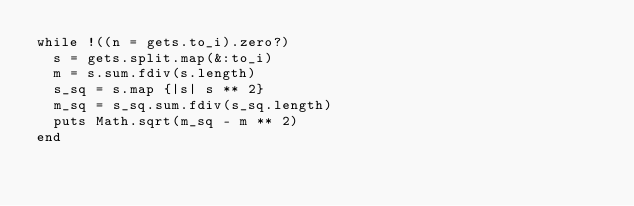<code> <loc_0><loc_0><loc_500><loc_500><_Ruby_>while !((n = gets.to_i).zero?)
  s = gets.split.map(&:to_i)
  m = s.sum.fdiv(s.length)
  s_sq = s.map {|s| s ** 2}
  m_sq = s_sq.sum.fdiv(s_sq.length)
  puts Math.sqrt(m_sq - m ** 2)
end
</code> 